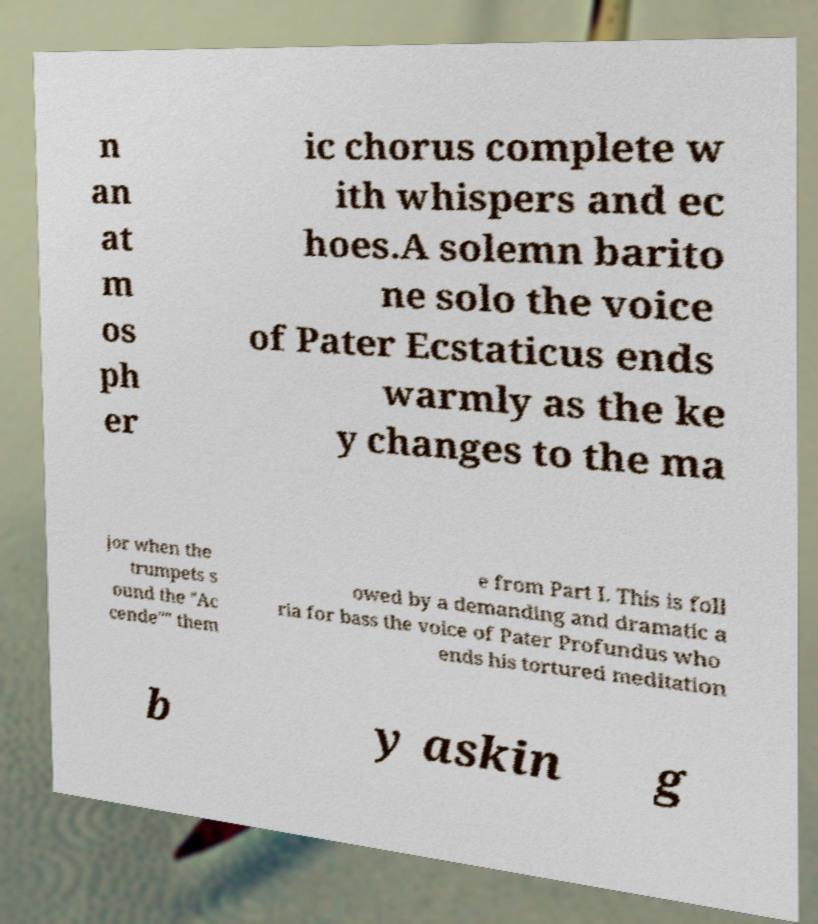There's text embedded in this image that I need extracted. Can you transcribe it verbatim? n an at m os ph er ic chorus complete w ith whispers and ec hoes.A solemn barito ne solo the voice of Pater Ecstaticus ends warmly as the ke y changes to the ma jor when the trumpets s ound the "Ac cende"" them e from Part I. This is foll owed by a demanding and dramatic a ria for bass the voice of Pater Profundus who ends his tortured meditation b y askin g 